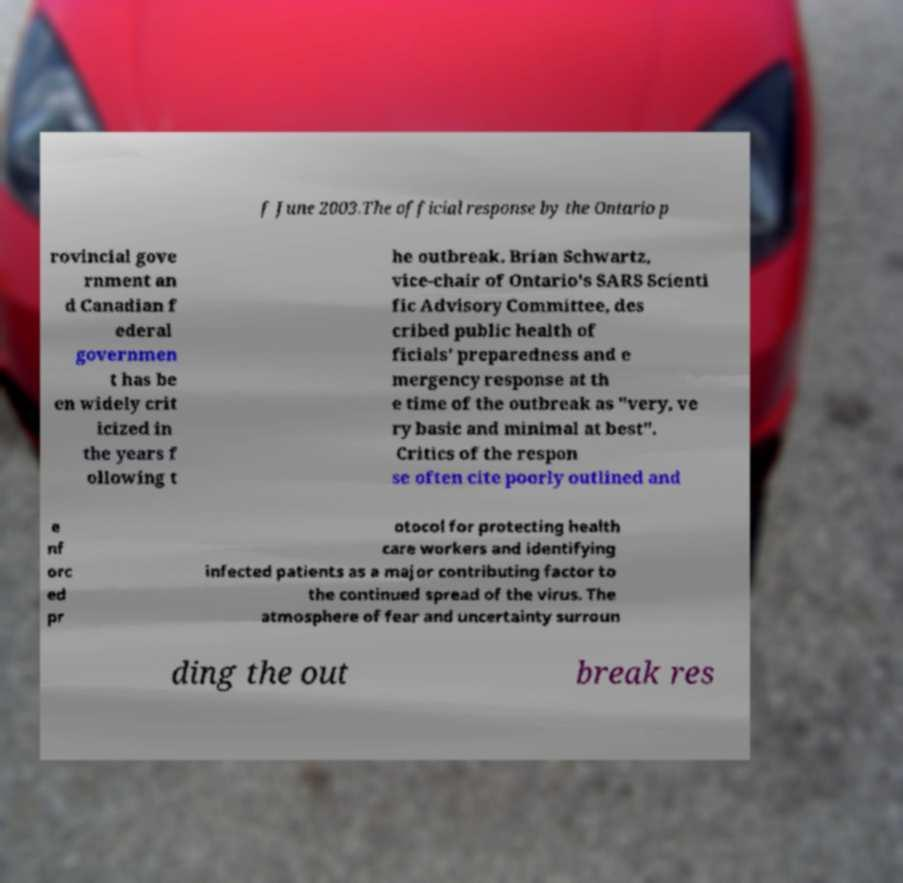What messages or text are displayed in this image? I need them in a readable, typed format. f June 2003.The official response by the Ontario p rovincial gove rnment an d Canadian f ederal governmen t has be en widely crit icized in the years f ollowing t he outbreak. Brian Schwartz, vice-chair of Ontario's SARS Scienti fic Advisory Committee, des cribed public health of ficials' preparedness and e mergency response at th e time of the outbreak as "very, ve ry basic and minimal at best". Critics of the respon se often cite poorly outlined and e nf orc ed pr otocol for protecting health care workers and identifying infected patients as a major contributing factor to the continued spread of the virus. The atmosphere of fear and uncertainty surroun ding the out break res 